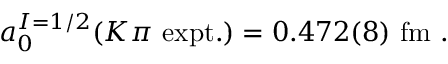<formula> <loc_0><loc_0><loc_500><loc_500>a _ { 0 } ^ { I = 1 / 2 } ( K \pi \ e x p t . ) = 0 . 4 7 2 ( 8 ) \ f m \ .</formula> 